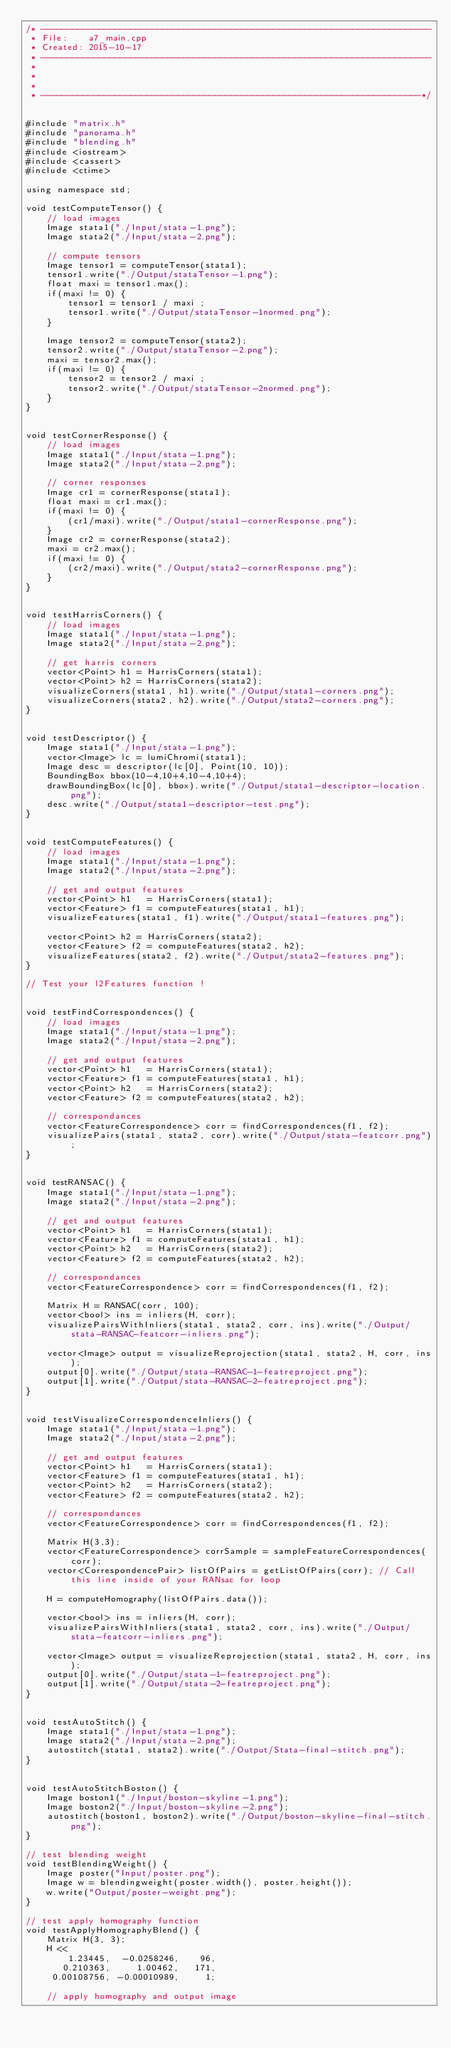<code> <loc_0><loc_0><loc_500><loc_500><_C++_>/* --------------------------------------------------------------------------
 * File:    a7_main.cpp
 * Created: 2015-10-17
 * --------------------------------------------------------------------------
 *
 *
 *
 * ------------------------------------------------------------------------*/


#include "matrix.h"
#include "panorama.h"
#include "blending.h"
#include <iostream>
#include <cassert>
#include <ctime>

using namespace std;

void testComputeTensor() {
    // load images
    Image stata1("./Input/stata-1.png");
    Image stata2("./Input/stata-2.png");

    // compute tensors
    Image tensor1 = computeTensor(stata1);
    tensor1.write("./Output/stataTensor-1.png");
    float maxi = tensor1.max();
    if(maxi != 0) {
        tensor1 = tensor1 / maxi ;
        tensor1.write("./Output/stataTensor-1normed.png");
    }

    Image tensor2 = computeTensor(stata2);
    tensor2.write("./Output/stataTensor-2.png");
    maxi = tensor2.max();
    if(maxi != 0) {
        tensor2 = tensor2 / maxi ;
        tensor2.write("./Output/stataTensor-2normed.png");
    }
}


void testCornerResponse() {
    // load images
    Image stata1("./Input/stata-1.png");
    Image stata2("./Input/stata-2.png");

    // corner responses
    Image cr1 = cornerResponse(stata1);
    float maxi = cr1.max();
    if(maxi != 0) {
        (cr1/maxi).write("./Output/stata1-cornerResponse.png");
    }
    Image cr2 = cornerResponse(stata2);
    maxi = cr2.max();
    if(maxi != 0) {
        (cr2/maxi).write("./Output/stata2-cornerResponse.png");
    }
}


void testHarrisCorners() {
    // load images
    Image stata1("./Input/stata-1.png");
    Image stata2("./Input/stata-2.png");

    // get harris corners
    vector<Point> h1 = HarrisCorners(stata1);
    vector<Point> h2 = HarrisCorners(stata2);
    visualizeCorners(stata1, h1).write("./Output/stata1-corners.png");
    visualizeCorners(stata2, h2).write("./Output/stata2-corners.png");
}


void testDescriptor() {
    Image stata1("./Input/stata-1.png");
    vector<Image> lc = lumiChromi(stata1);
    Image desc = descriptor(lc[0], Point(10, 10));
    BoundingBox bbox(10-4,10+4,10-4,10+4);
    drawBoundingBox(lc[0], bbox).write("./Output/stata1-descriptor-location.png");
    desc.write("./Output/stata1-descriptor-test.png");
}


void testComputeFeatures() {
    // load images
    Image stata1("./Input/stata-1.png");
    Image stata2("./Input/stata-2.png");

    // get and output features
    vector<Point> h1   = HarrisCorners(stata1);
    vector<Feature> f1 = computeFeatures(stata1, h1);
    visualizeFeatures(stata1, f1).write("./Output/stata1-features.png");

    vector<Point> h2 = HarrisCorners(stata2);
    vector<Feature> f2 = computeFeatures(stata2, h2);
    visualizeFeatures(stata2, f2).write("./Output/stata2-features.png");
}

// Test your l2Features function !


void testFindCorrespondences() {
    // load images
    Image stata1("./Input/stata-1.png");
    Image stata2("./Input/stata-2.png");

    // get and output features
    vector<Point> h1   = HarrisCorners(stata1);
    vector<Feature> f1 = computeFeatures(stata1, h1);
    vector<Point> h2   = HarrisCorners(stata2);
    vector<Feature> f2 = computeFeatures(stata2, h2);

    // correspondances
    vector<FeatureCorrespondence> corr = findCorrespondences(f1, f2);
    visualizePairs(stata1, stata2, corr).write("./Output/stata-featcorr.png");
}


void testRANSAC() {
    Image stata1("./Input/stata-1.png");
    Image stata2("./Input/stata-2.png");

    // get and output features
    vector<Point> h1   = HarrisCorners(stata1);
    vector<Feature> f1 = computeFeatures(stata1, h1);
    vector<Point> h2   = HarrisCorners(stata2);
    vector<Feature> f2 = computeFeatures(stata2, h2);

    // correspondances
    vector<FeatureCorrespondence> corr = findCorrespondences(f1, f2);

    Matrix H = RANSAC(corr, 100);
    vector<bool> ins = inliers(H, corr);
    visualizePairsWithInliers(stata1, stata2, corr, ins).write("./Output/stata-RANSAC-featcorr-inliers.png");

    vector<Image> output = visualizeReprojection(stata1, stata2, H, corr, ins);
    output[0].write("./Output/stata-RANSAC-1-featreproject.png");
    output[1].write("./Output/stata-RANSAC-2-featreproject.png");
}


void testVisualizeCorrespondenceInliers() {
    Image stata1("./Input/stata-1.png");
    Image stata2("./Input/stata-2.png");

    // get and output features
    vector<Point> h1   = HarrisCorners(stata1);
    vector<Feature> f1 = computeFeatures(stata1, h1);
    vector<Point> h2   = HarrisCorners(stata2);
    vector<Feature> f2 = computeFeatures(stata2, h2);

    // correspondances
    vector<FeatureCorrespondence> corr = findCorrespondences(f1, f2);

    Matrix H(3,3);
    vector<FeatureCorrespondence> corrSample = sampleFeatureCorrespondences(corr);
    vector<CorrespondencePair> listOfPairs = getListOfPairs(corr); // Call this line inside of your RANsac for loop

    H = computeHomography(listOfPairs.data());

    vector<bool> ins = inliers(H, corr);
    visualizePairsWithInliers(stata1, stata2, corr, ins).write("./Output/stata-featcorr-inliers.png");

    vector<Image> output = visualizeReprojection(stata1, stata2, H, corr, ins);
    output[0].write("./Output/stata-1-featreproject.png");
    output[1].write("./Output/stata-2-featreproject.png");
}


void testAutoStitch() {
    Image stata1("./Input/stata-1.png");
    Image stata2("./Input/stata-2.png");
    autostitch(stata1, stata2).write("./Output/Stata-final-stitch.png");
}


void testAutoStitchBoston() {
    Image boston1("./Input/boston-skyline-1.png");
    Image boston2("./Input/boston-skyline-2.png");
    autostitch(boston1, boston2).write("./Output/boston-skyline-final-stitch.png");
}

// test blending weight
void testBlendingWeight() {
    Image poster("Input/poster.png");
    Image w = blendingweight(poster.width(), poster.height());
    w.write("Output/poster-weight.png");
}

// test apply homography function
void testApplyHomographyBlend() {
    Matrix H(3, 3);
    H <<
        1.23445,  -0.0258246,    96,
       0.210363,     1.00462,   171,
     0.00108756, -0.00010989,     1;

    // apply homography and output image</code> 